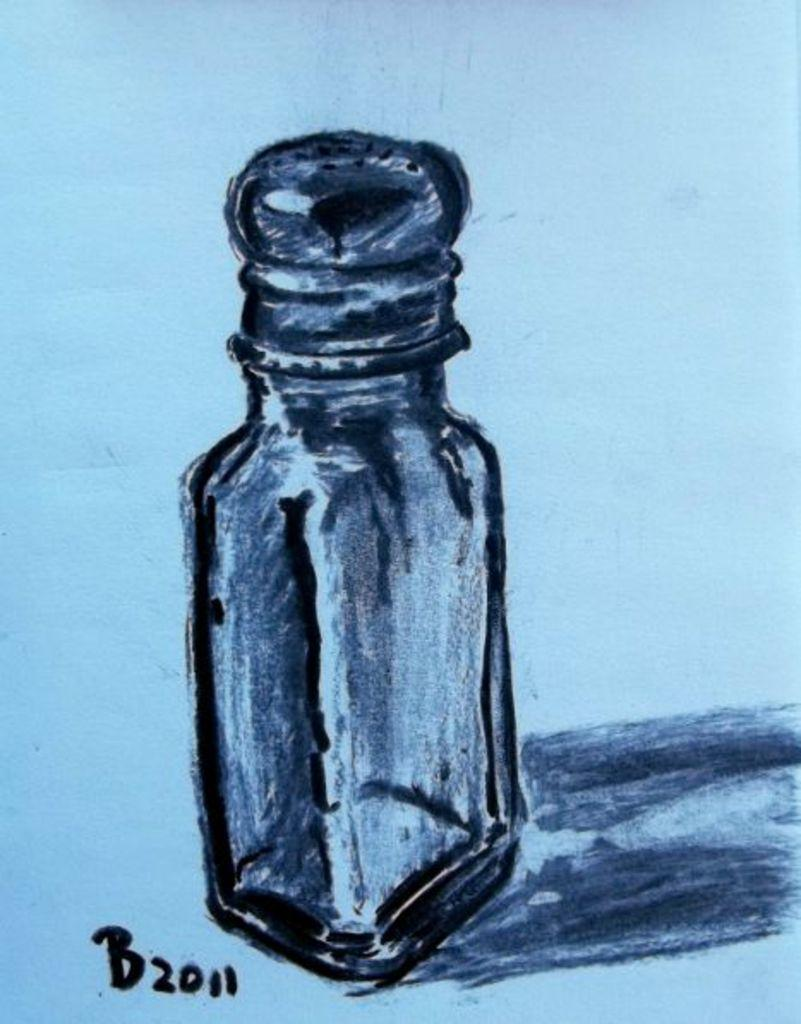<image>
Summarize the visual content of the image. A drawing of a salt shaker is initialed B with the year 2011. 